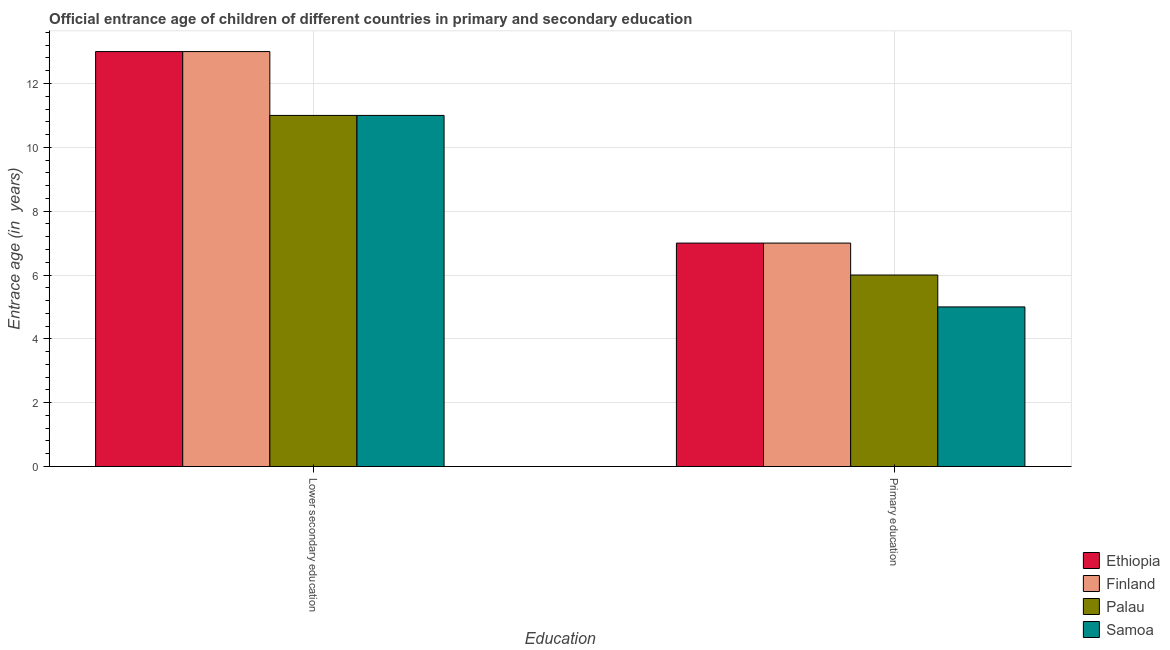How many different coloured bars are there?
Your answer should be very brief. 4. How many bars are there on the 2nd tick from the left?
Offer a terse response. 4. How many bars are there on the 2nd tick from the right?
Your answer should be very brief. 4. What is the label of the 1st group of bars from the left?
Offer a very short reply. Lower secondary education. What is the entrance age of children in lower secondary education in Samoa?
Provide a succinct answer. 11. Across all countries, what is the maximum entrance age of chiildren in primary education?
Provide a succinct answer. 7. Across all countries, what is the minimum entrance age of chiildren in primary education?
Your response must be concise. 5. In which country was the entrance age of chiildren in primary education maximum?
Your response must be concise. Ethiopia. In which country was the entrance age of chiildren in primary education minimum?
Make the answer very short. Samoa. What is the total entrance age of chiildren in primary education in the graph?
Ensure brevity in your answer.  25. What is the difference between the entrance age of children in lower secondary education in Samoa and that in Ethiopia?
Your answer should be compact. -2. What is the difference between the entrance age of children in lower secondary education in Samoa and the entrance age of chiildren in primary education in Palau?
Offer a terse response. 5. What is the average entrance age of chiildren in primary education per country?
Provide a short and direct response. 6.25. What is the difference between the entrance age of chiildren in primary education and entrance age of children in lower secondary education in Samoa?
Your answer should be compact. -6. What is the ratio of the entrance age of children in lower secondary education in Palau to that in Ethiopia?
Make the answer very short. 0.85. Is the entrance age of chiildren in primary education in Ethiopia less than that in Palau?
Make the answer very short. No. In how many countries, is the entrance age of chiildren in primary education greater than the average entrance age of chiildren in primary education taken over all countries?
Give a very brief answer. 2. What does the 3rd bar from the left in Primary education represents?
Keep it short and to the point. Palau. What does the 2nd bar from the right in Lower secondary education represents?
Offer a terse response. Palau. Does the graph contain any zero values?
Provide a short and direct response. No. What is the title of the graph?
Your response must be concise. Official entrance age of children of different countries in primary and secondary education. Does "Italy" appear as one of the legend labels in the graph?
Make the answer very short. No. What is the label or title of the X-axis?
Ensure brevity in your answer.  Education. What is the label or title of the Y-axis?
Offer a terse response. Entrace age (in  years). What is the Entrace age (in  years) of Palau in Lower secondary education?
Give a very brief answer. 11. What is the Entrace age (in  years) in Finland in Primary education?
Offer a very short reply. 7. Across all Education, what is the maximum Entrace age (in  years) in Ethiopia?
Provide a short and direct response. 13. Across all Education, what is the maximum Entrace age (in  years) of Palau?
Provide a succinct answer. 11. Across all Education, what is the minimum Entrace age (in  years) in Finland?
Provide a succinct answer. 7. Across all Education, what is the minimum Entrace age (in  years) in Palau?
Make the answer very short. 6. What is the total Entrace age (in  years) of Ethiopia in the graph?
Make the answer very short. 20. What is the total Entrace age (in  years) of Samoa in the graph?
Offer a terse response. 16. What is the difference between the Entrace age (in  years) of Ethiopia in Lower secondary education and that in Primary education?
Provide a succinct answer. 6. What is the difference between the Entrace age (in  years) in Ethiopia in Lower secondary education and the Entrace age (in  years) in Palau in Primary education?
Provide a succinct answer. 7. What is the difference between the Entrace age (in  years) of Palau in Lower secondary education and the Entrace age (in  years) of Samoa in Primary education?
Offer a terse response. 6. What is the average Entrace age (in  years) of Ethiopia per Education?
Provide a short and direct response. 10. What is the average Entrace age (in  years) of Finland per Education?
Your response must be concise. 10. What is the average Entrace age (in  years) in Palau per Education?
Offer a very short reply. 8.5. What is the average Entrace age (in  years) in Samoa per Education?
Ensure brevity in your answer.  8. What is the difference between the Entrace age (in  years) in Ethiopia and Entrace age (in  years) in Samoa in Lower secondary education?
Give a very brief answer. 2. What is the difference between the Entrace age (in  years) of Ethiopia and Entrace age (in  years) of Palau in Primary education?
Provide a short and direct response. 1. What is the difference between the Entrace age (in  years) in Finland and Entrace age (in  years) in Palau in Primary education?
Your answer should be very brief. 1. What is the ratio of the Entrace age (in  years) in Ethiopia in Lower secondary education to that in Primary education?
Your answer should be very brief. 1.86. What is the ratio of the Entrace age (in  years) of Finland in Lower secondary education to that in Primary education?
Keep it short and to the point. 1.86. What is the ratio of the Entrace age (in  years) of Palau in Lower secondary education to that in Primary education?
Keep it short and to the point. 1.83. What is the difference between the highest and the second highest Entrace age (in  years) of Palau?
Provide a succinct answer. 5. What is the difference between the highest and the lowest Entrace age (in  years) of Ethiopia?
Offer a very short reply. 6. What is the difference between the highest and the lowest Entrace age (in  years) in Palau?
Your answer should be compact. 5. What is the difference between the highest and the lowest Entrace age (in  years) in Samoa?
Provide a succinct answer. 6. 